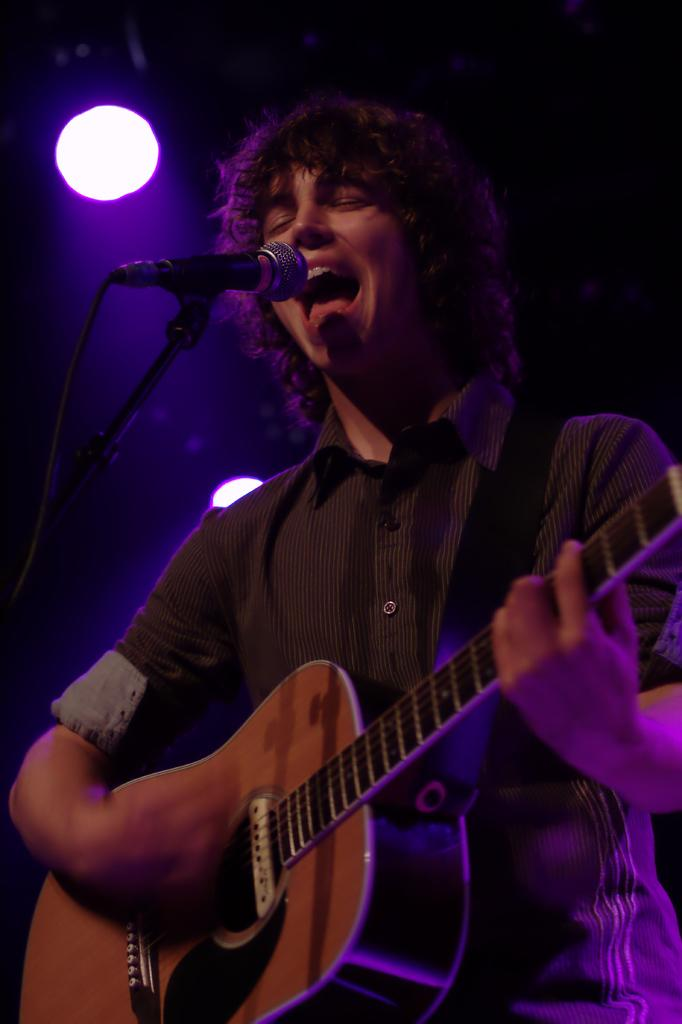What is the man in the image doing? The man is playing the guitar and singing through the microphone. What object is the man holding in the image? The man is holding a guitar. What is the purpose of the microphone in the image? The microphone is being used by the man to amplify his singing. Is the man in jail in the image? No, there is no indication in the image that the man is in jail. What type of club is the man performing at in the image? There is no club present in the image, and the man's location is not specified as a club. 